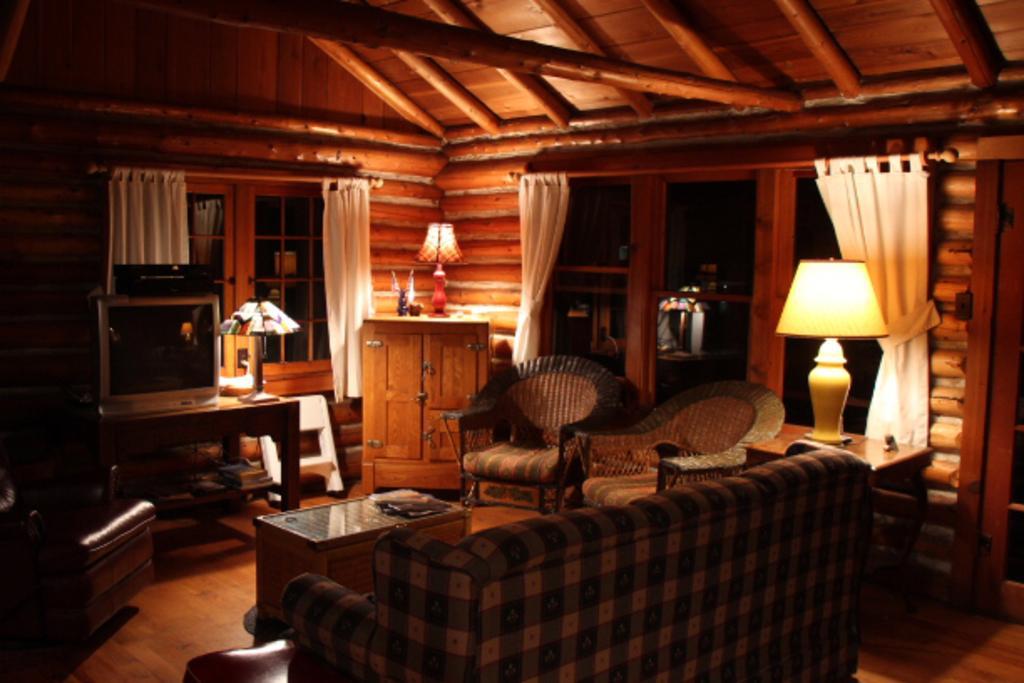Can you describe this image briefly? This is looks like a living room. This is a couch. These are the two wooden chairs. This is a teapoy with something on it. This is the television placed on the table. These are the lamps. I can see another big lamp placed on the table beside the couch. I can see another chair here. This looks like a small wardrobe. These are the windows with curtains hanging to the hanger. This is the wooden rooftop. 